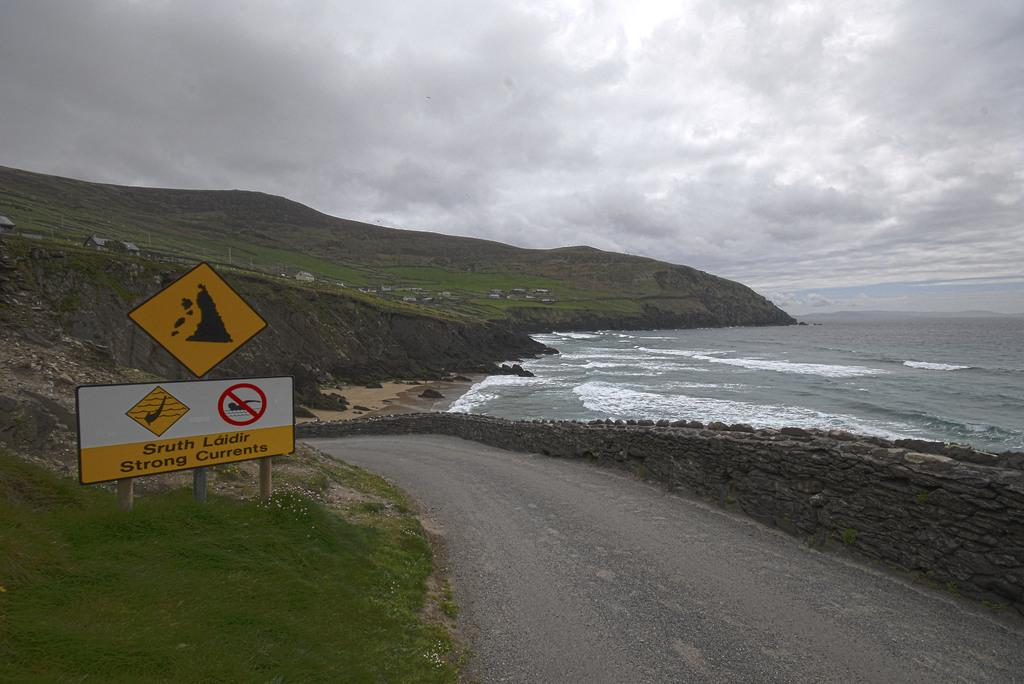<image>
Share a concise interpretation of the image provided. A sign warning of a strong current in the water. 